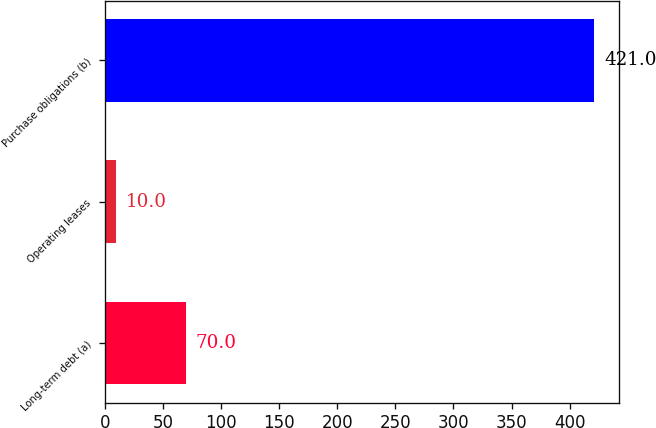Convert chart to OTSL. <chart><loc_0><loc_0><loc_500><loc_500><bar_chart><fcel>Long-term debt (a)<fcel>Operating leases<fcel>Purchase obligations (b)<nl><fcel>70<fcel>10<fcel>421<nl></chart> 